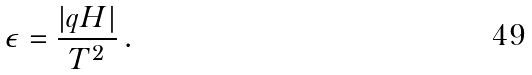<formula> <loc_0><loc_0><loc_500><loc_500>\epsilon = \frac { | q H | } { T ^ { 2 } } \, .</formula> 